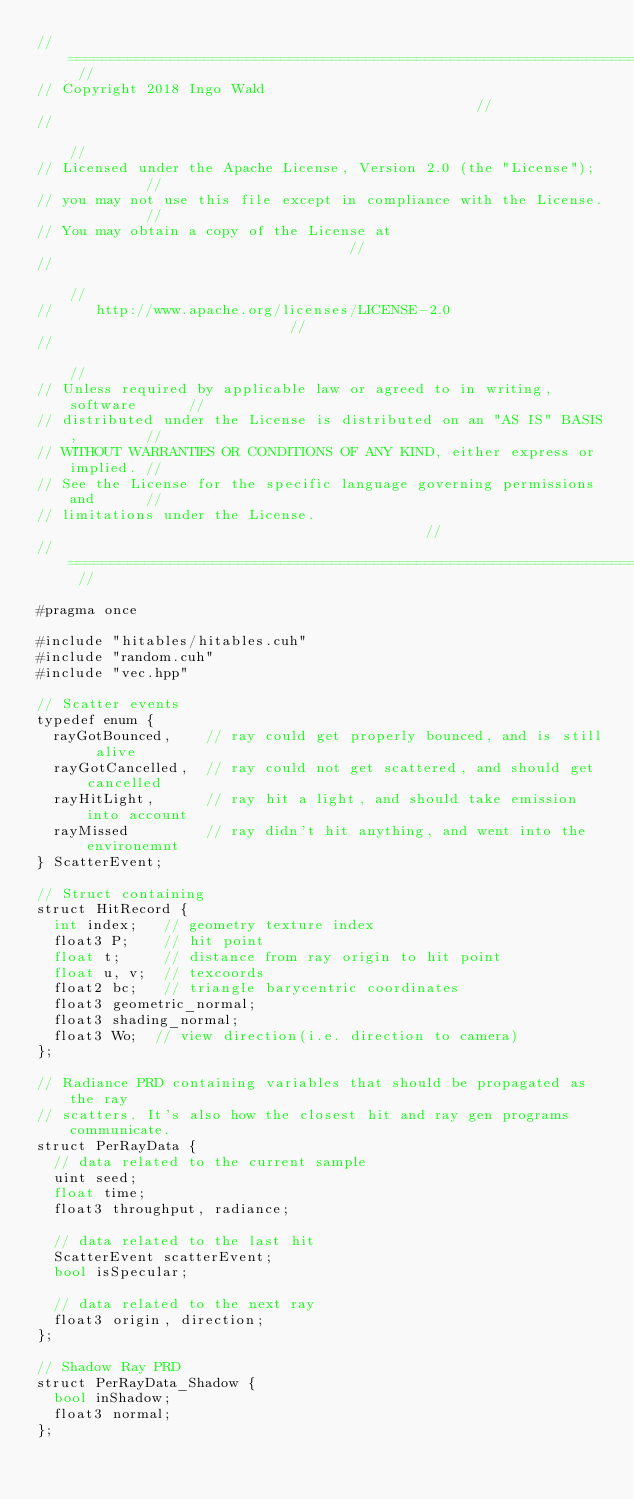Convert code to text. <code><loc_0><loc_0><loc_500><loc_500><_Cuda_>// ======================================================================== //
// Copyright 2018 Ingo Wald                                                 //
//                                                                          //
// Licensed under the Apache License, Version 2.0 (the "License");          //
// you may not use this file except in compliance with the License.         //
// You may obtain a copy of the License at                                  //
//                                                                          //
//     http://www.apache.org/licenses/LICENSE-2.0                           //
//                                                                          //
// Unless required by applicable law or agreed to in writing, software      //
// distributed under the License is distributed on an "AS IS" BASIS,        //
// WITHOUT WARRANTIES OR CONDITIONS OF ANY KIND, either express or implied. //
// See the License for the specific language governing permissions and      //
// limitations under the License.                                           //
// ======================================================================== //

#pragma once

#include "hitables/hitables.cuh"
#include "random.cuh"
#include "vec.hpp"

// Scatter events
typedef enum {
  rayGotBounced,    // ray could get properly bounced, and is still alive
  rayGotCancelled,  // ray could not get scattered, and should get cancelled
  rayHitLight,      // ray hit a light, and should take emission into account
  rayMissed         // ray didn't hit anything, and went into the environemnt
} ScatterEvent;

// Struct containing
struct HitRecord {
  int index;   // geometry texture index
  float3 P;    // hit point
  float t;     // distance from ray origin to hit point
  float u, v;  // texcoords
  float2 bc;   // triangle barycentric coordinates
  float3 geometric_normal;
  float3 shading_normal;
  float3 Wo;  // view direction(i.e. direction to camera)
};

// Radiance PRD containing variables that should be propagated as the ray
// scatters. It's also how the closest hit and ray gen programs communicate.
struct PerRayData {
  // data related to the current sample
  uint seed;
  float time;
  float3 throughput, radiance;

  // data related to the last hit
  ScatterEvent scatterEvent;
  bool isSpecular;

  // data related to the next ray
  float3 origin, direction;
};

// Shadow Ray PRD
struct PerRayData_Shadow {
  bool inShadow;
  float3 normal;
};
</code> 